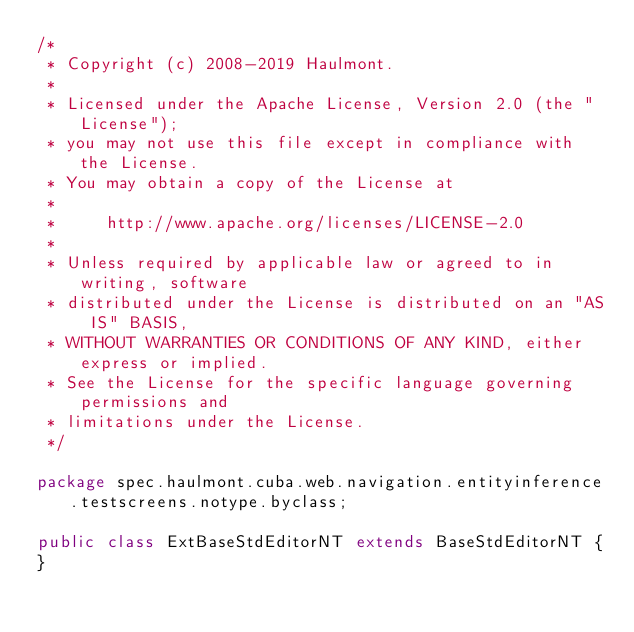Convert code to text. <code><loc_0><loc_0><loc_500><loc_500><_Java_>/*
 * Copyright (c) 2008-2019 Haulmont.
 *
 * Licensed under the Apache License, Version 2.0 (the "License");
 * you may not use this file except in compliance with the License.
 * You may obtain a copy of the License at
 *
 *     http://www.apache.org/licenses/LICENSE-2.0
 *
 * Unless required by applicable law or agreed to in writing, software
 * distributed under the License is distributed on an "AS IS" BASIS,
 * WITHOUT WARRANTIES OR CONDITIONS OF ANY KIND, either express or implied.
 * See the License for the specific language governing permissions and
 * limitations under the License.
 */

package spec.haulmont.cuba.web.navigation.entityinference.testscreens.notype.byclass;

public class ExtBaseStdEditorNT extends BaseStdEditorNT {
}
</code> 